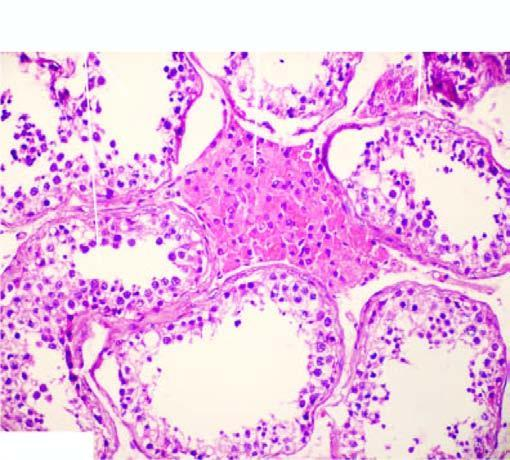where is prominence of leydig cells?
Answer the question using a single word or phrase. The interstitium 